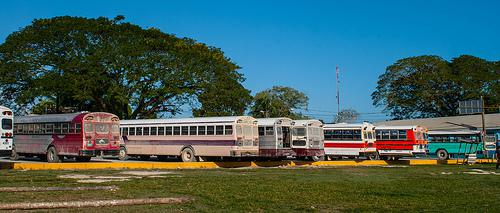Question: how many busses are visible?
Choices:
A. Eight.
B. Seven.
C. Five.
D. Six.
Answer with the letter. Answer: A Question: what color is the third bus from the left?
Choices:
A. Red.
B. White.
C. Blue.
D. Peach.
Answer with the letter. Answer: D 